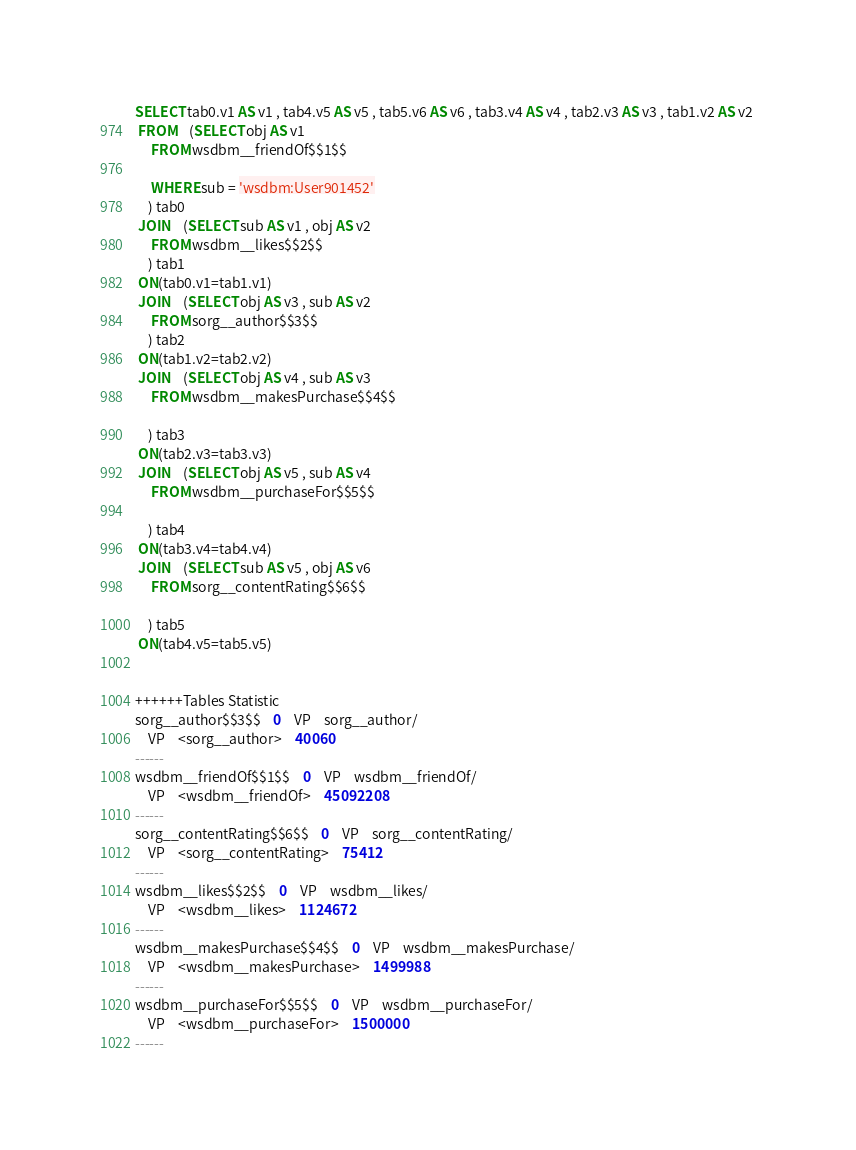<code> <loc_0><loc_0><loc_500><loc_500><_SQL_>SELECT tab0.v1 AS v1 , tab4.v5 AS v5 , tab5.v6 AS v6 , tab3.v4 AS v4 , tab2.v3 AS v3 , tab1.v2 AS v2 
 FROM    (SELECT obj AS v1 
	 FROM wsdbm__friendOf$$1$$
	 
	 WHERE sub = 'wsdbm:User901452'
	) tab0
 JOIN    (SELECT sub AS v1 , obj AS v2 
	 FROM wsdbm__likes$$2$$
	) tab1
 ON(tab0.v1=tab1.v1)
 JOIN    (SELECT obj AS v3 , sub AS v2 
	 FROM sorg__author$$3$$
	) tab2
 ON(tab1.v2=tab2.v2)
 JOIN    (SELECT obj AS v4 , sub AS v3 
	 FROM wsdbm__makesPurchase$$4$$
	
	) tab3
 ON(tab2.v3=tab3.v3)
 JOIN    (SELECT obj AS v5 , sub AS v4 
	 FROM wsdbm__purchaseFor$$5$$
	
	) tab4
 ON(tab3.v4=tab4.v4)
 JOIN    (SELECT sub AS v5 , obj AS v6 
	 FROM sorg__contentRating$$6$$
	
	) tab5
 ON(tab4.v5=tab5.v5)


++++++Tables Statistic
sorg__author$$3$$	0	VP	sorg__author/
	VP	<sorg__author>	40060
------
wsdbm__friendOf$$1$$	0	VP	wsdbm__friendOf/
	VP	<wsdbm__friendOf>	45092208
------
sorg__contentRating$$6$$	0	VP	sorg__contentRating/
	VP	<sorg__contentRating>	75412
------
wsdbm__likes$$2$$	0	VP	wsdbm__likes/
	VP	<wsdbm__likes>	1124672
------
wsdbm__makesPurchase$$4$$	0	VP	wsdbm__makesPurchase/
	VP	<wsdbm__makesPurchase>	1499988
------
wsdbm__purchaseFor$$5$$	0	VP	wsdbm__purchaseFor/
	VP	<wsdbm__purchaseFor>	1500000
------
</code> 